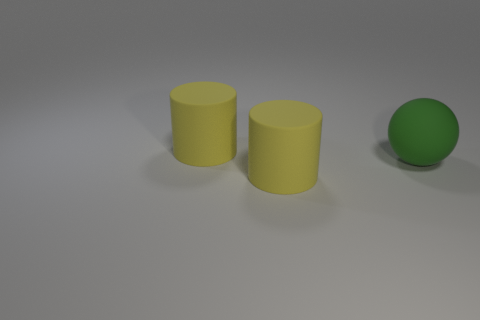Add 1 green rubber objects. How many objects exist? 4 Subtract all cylinders. How many objects are left? 1 Subtract all large green rubber objects. Subtract all yellow cylinders. How many objects are left? 0 Add 1 big rubber cylinders. How many big rubber cylinders are left? 3 Add 3 big green objects. How many big green objects exist? 4 Subtract 0 green cubes. How many objects are left? 3 Subtract all blue cylinders. Subtract all brown blocks. How many cylinders are left? 2 